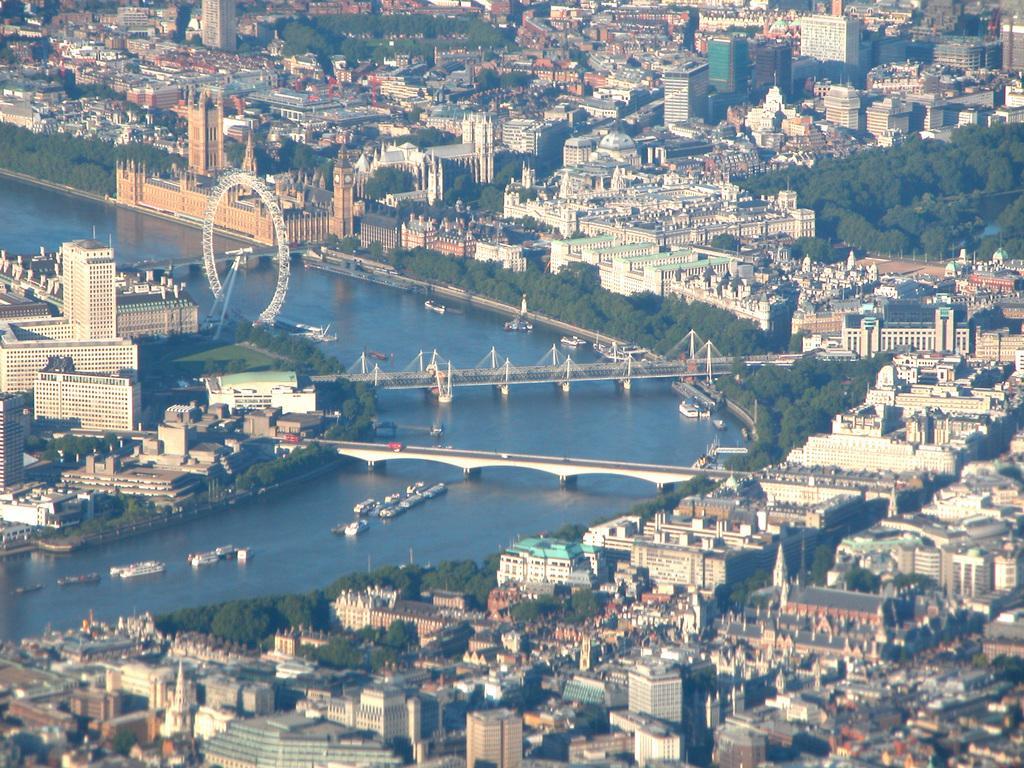How would you summarize this image in a sentence or two? In this image I can see water in the centre and on it I can see number of boats. On the both side of the water I can see number of trees, number of buildings and over the water I can see three bridges. 